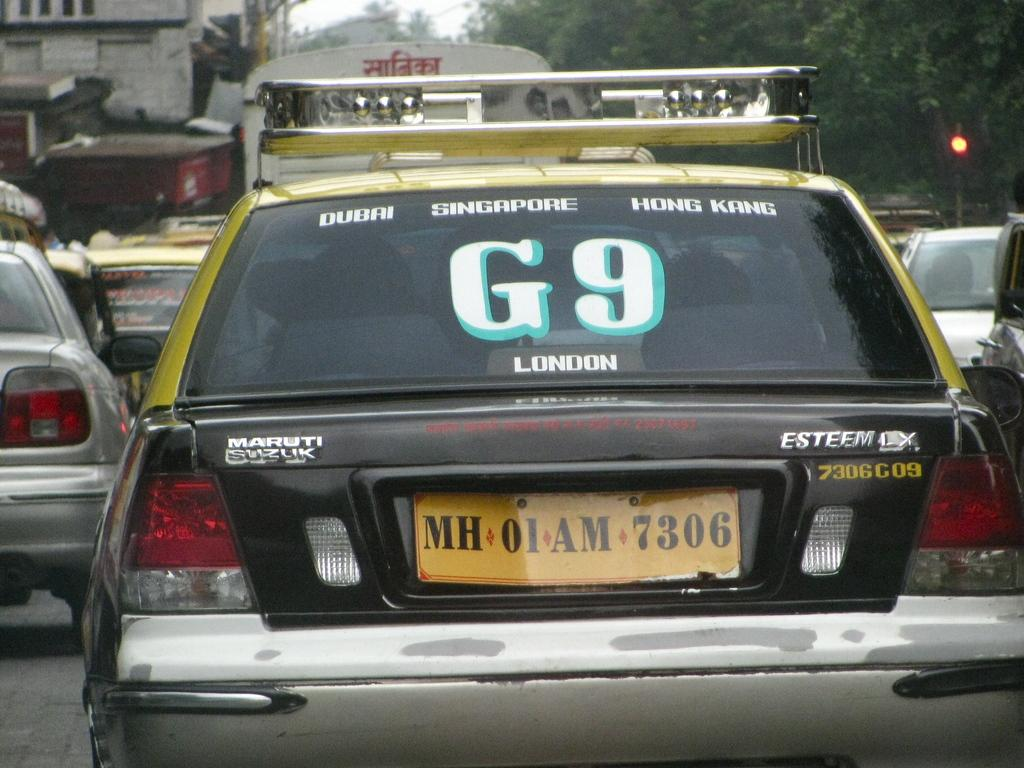<image>
Share a concise interpretation of the image provided. The back of a car with decals in the window with place names like Dubai, Singapore, and Hong Kong. 